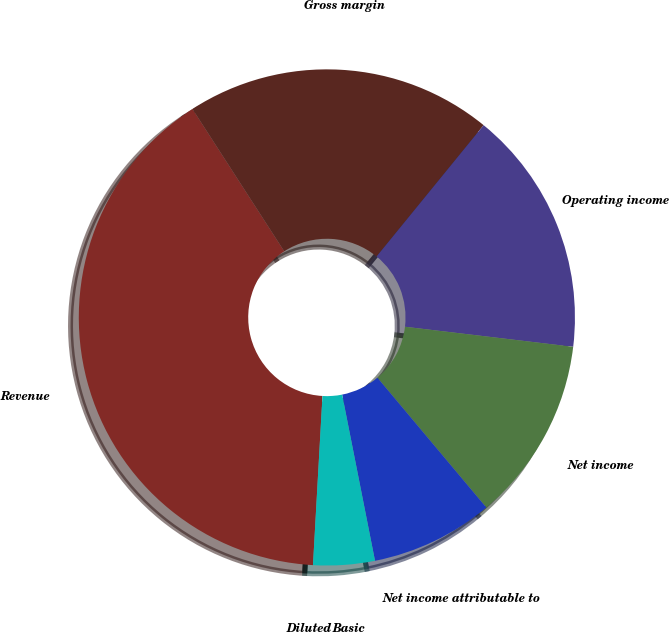Convert chart. <chart><loc_0><loc_0><loc_500><loc_500><pie_chart><fcel>Revenue<fcel>Gross margin<fcel>Operating income<fcel>Net income<fcel>Net income attributable to<fcel>Basic<fcel>Diluted<nl><fcel>39.99%<fcel>20.0%<fcel>16.0%<fcel>12.0%<fcel>8.0%<fcel>4.0%<fcel>0.0%<nl></chart> 